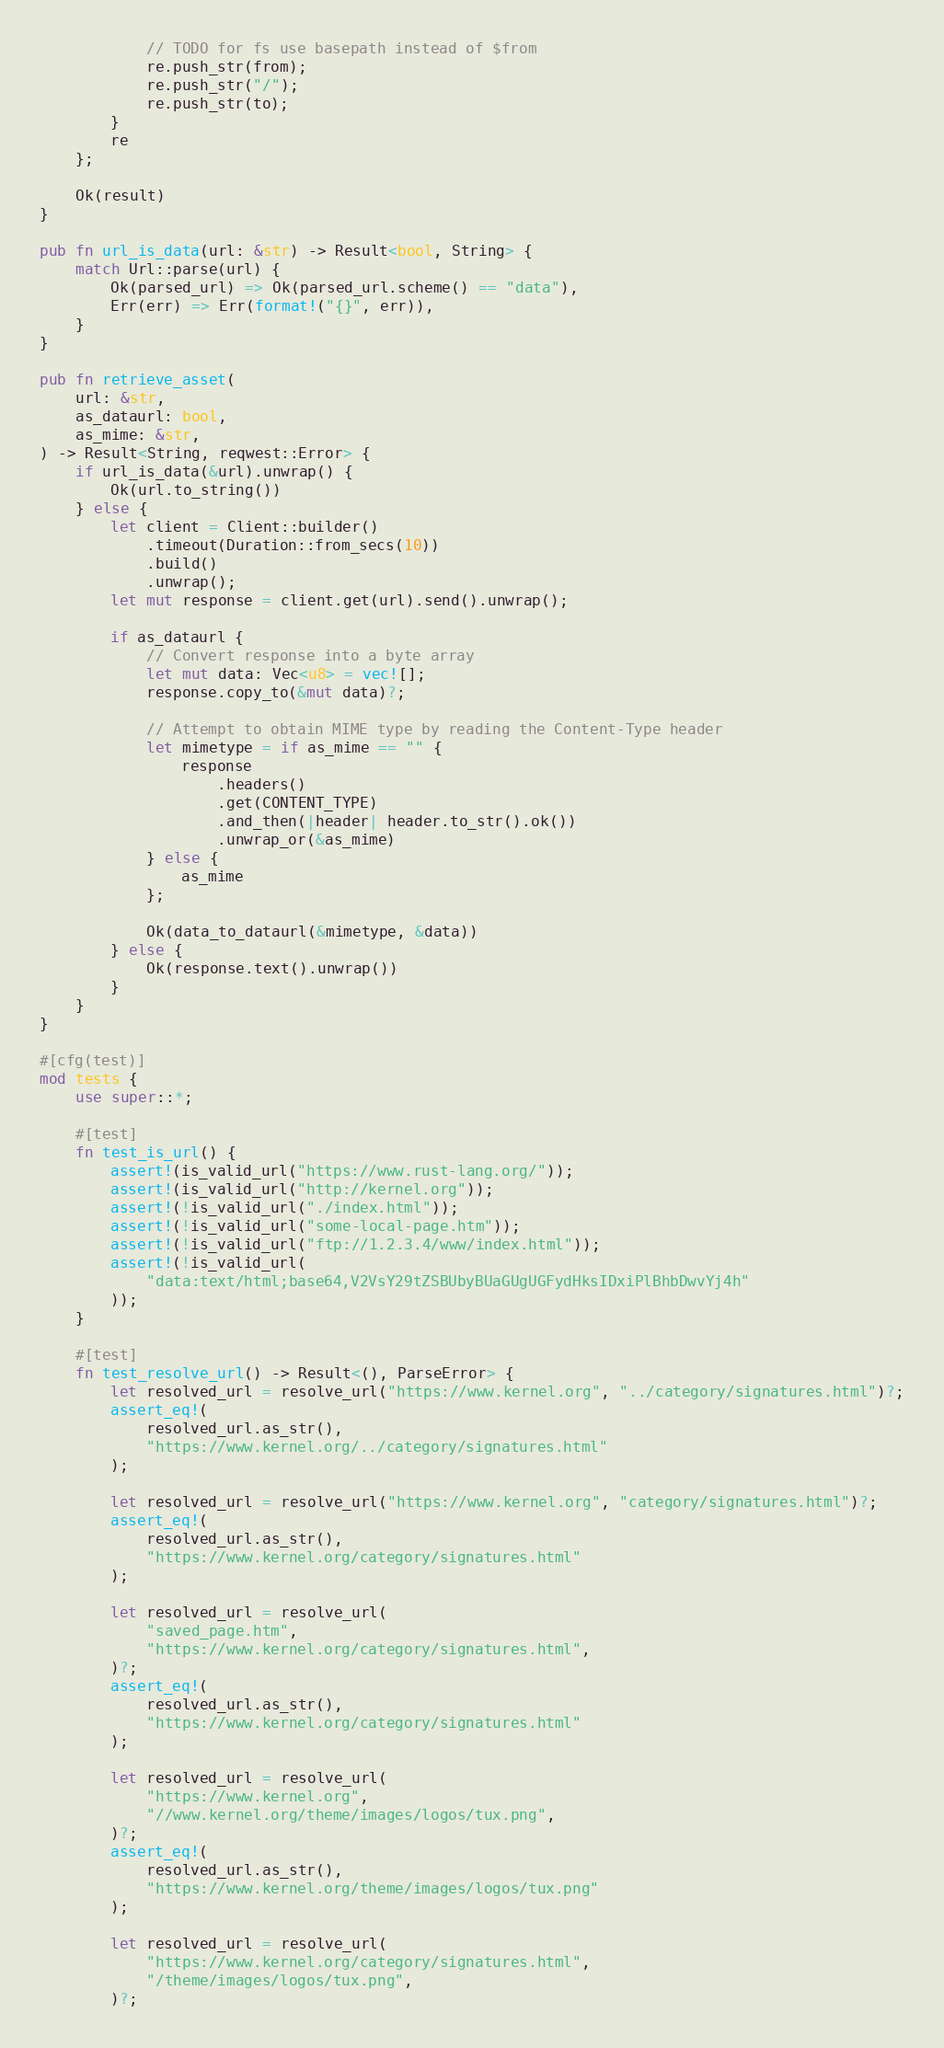Convert code to text. <code><loc_0><loc_0><loc_500><loc_500><_Rust_>            // TODO for fs use basepath instead of $from
            re.push_str(from);
            re.push_str("/");
            re.push_str(to);
        }
        re
    };

    Ok(result)
}

pub fn url_is_data(url: &str) -> Result<bool, String> {
    match Url::parse(url) {
        Ok(parsed_url) => Ok(parsed_url.scheme() == "data"),
        Err(err) => Err(format!("{}", err)),
    }
}

pub fn retrieve_asset(
    url: &str,
    as_dataurl: bool,
    as_mime: &str,
) -> Result<String, reqwest::Error> {
    if url_is_data(&url).unwrap() {
        Ok(url.to_string())
    } else {
        let client = Client::builder()
            .timeout(Duration::from_secs(10))
            .build()
            .unwrap();
        let mut response = client.get(url).send().unwrap();

        if as_dataurl {
            // Convert response into a byte array
            let mut data: Vec<u8> = vec![];
            response.copy_to(&mut data)?;

            // Attempt to obtain MIME type by reading the Content-Type header
            let mimetype = if as_mime == "" {
                response
                    .headers()
                    .get(CONTENT_TYPE)
                    .and_then(|header| header.to_str().ok())
                    .unwrap_or(&as_mime)
            } else {
                as_mime
            };

            Ok(data_to_dataurl(&mimetype, &data))
        } else {
            Ok(response.text().unwrap())
        }
    }
}

#[cfg(test)]
mod tests {
    use super::*;

    #[test]
    fn test_is_url() {
        assert!(is_valid_url("https://www.rust-lang.org/"));
        assert!(is_valid_url("http://kernel.org"));
        assert!(!is_valid_url("./index.html"));
        assert!(!is_valid_url("some-local-page.htm"));
        assert!(!is_valid_url("ftp://1.2.3.4/www/index.html"));
        assert!(!is_valid_url(
            "data:text/html;base64,V2VsY29tZSBUbyBUaGUgUGFydHksIDxiPlBhbDwvYj4h"
        ));
    }

    #[test]
    fn test_resolve_url() -> Result<(), ParseError> {
        let resolved_url = resolve_url("https://www.kernel.org", "../category/signatures.html")?;
        assert_eq!(
            resolved_url.as_str(),
            "https://www.kernel.org/../category/signatures.html"
        );

        let resolved_url = resolve_url("https://www.kernel.org", "category/signatures.html")?;
        assert_eq!(
            resolved_url.as_str(),
            "https://www.kernel.org/category/signatures.html"
        );

        let resolved_url = resolve_url(
            "saved_page.htm",
            "https://www.kernel.org/category/signatures.html",
        )?;
        assert_eq!(
            resolved_url.as_str(),
            "https://www.kernel.org/category/signatures.html"
        );

        let resolved_url = resolve_url(
            "https://www.kernel.org",
            "//www.kernel.org/theme/images/logos/tux.png",
        )?;
        assert_eq!(
            resolved_url.as_str(),
            "https://www.kernel.org/theme/images/logos/tux.png"
        );

        let resolved_url = resolve_url(
            "https://www.kernel.org/category/signatures.html",
            "/theme/images/logos/tux.png",
        )?;</code> 